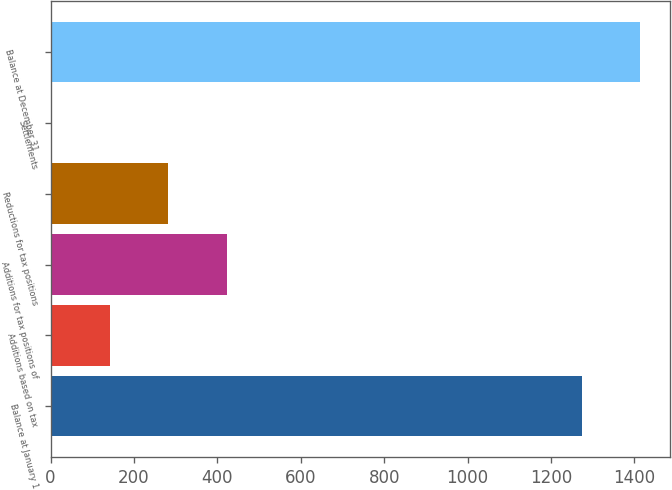<chart> <loc_0><loc_0><loc_500><loc_500><bar_chart><fcel>Balance at January 1<fcel>Additions based on tax<fcel>Additions for tax positions of<fcel>Reductions for tax positions<fcel>Settlements<fcel>Balance at December 31<nl><fcel>1274<fcel>142.7<fcel>422.1<fcel>282.4<fcel>3<fcel>1413.7<nl></chart> 